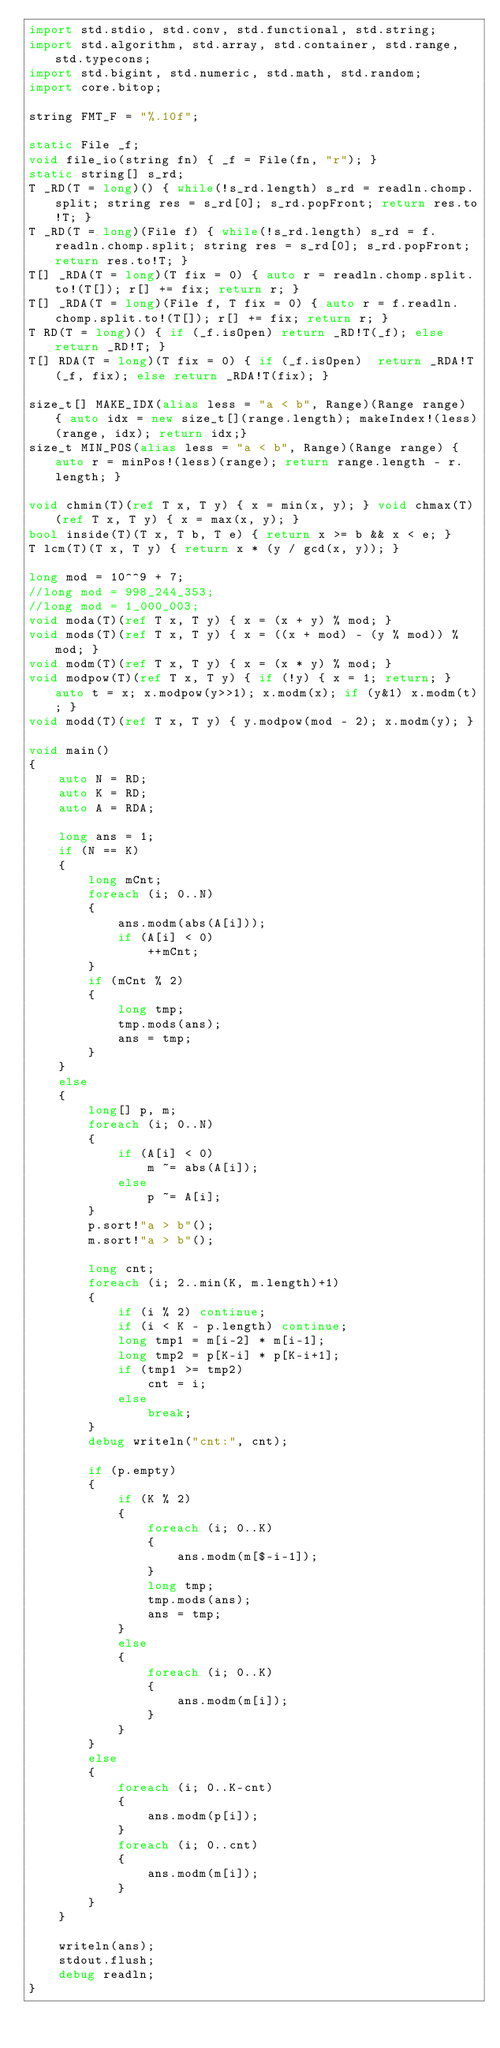Convert code to text. <code><loc_0><loc_0><loc_500><loc_500><_D_>import std.stdio, std.conv, std.functional, std.string;
import std.algorithm, std.array, std.container, std.range, std.typecons;
import std.bigint, std.numeric, std.math, std.random;
import core.bitop;

string FMT_F = "%.10f";

static File _f;
void file_io(string fn) { _f = File(fn, "r"); }
static string[] s_rd;
T _RD(T = long)() { while(!s_rd.length) s_rd = readln.chomp.split; string res = s_rd[0]; s_rd.popFront; return res.to!T; }
T _RD(T = long)(File f) { while(!s_rd.length) s_rd = f.readln.chomp.split; string res = s_rd[0]; s_rd.popFront; return res.to!T; }
T[] _RDA(T = long)(T fix = 0) { auto r = readln.chomp.split.to!(T[]); r[] += fix; return r; }
T[] _RDA(T = long)(File f, T fix = 0) { auto r = f.readln.chomp.split.to!(T[]); r[] += fix; return r; }
T RD(T = long)() { if (_f.isOpen) return _RD!T(_f); else return _RD!T; }
T[] RDA(T = long)(T fix = 0) { if (_f.isOpen)  return _RDA!T(_f, fix); else return _RDA!T(fix); }

size_t[] MAKE_IDX(alias less = "a < b", Range)(Range range) { auto idx = new size_t[](range.length); makeIndex!(less)(range, idx); return idx;}
size_t MIN_POS(alias less = "a < b", Range)(Range range) { auto r = minPos!(less)(range); return range.length - r.length; }

void chmin(T)(ref T x, T y) { x = min(x, y); } void chmax(T)(ref T x, T y) { x = max(x, y); }
bool inside(T)(T x, T b, T e) { return x >= b && x < e; }
T lcm(T)(T x, T y) { return x * (y / gcd(x, y)); }

long mod = 10^^9 + 7;
//long mod = 998_244_353;
//long mod = 1_000_003;
void moda(T)(ref T x, T y) { x = (x + y) % mod; }
void mods(T)(ref T x, T y) { x = ((x + mod) - (y % mod)) % mod; }
void modm(T)(ref T x, T y) { x = (x * y) % mod; }
void modpow(T)(ref T x, T y) { if (!y) { x = 1; return; } auto t = x; x.modpow(y>>1); x.modm(x); if (y&1) x.modm(t); }
void modd(T)(ref T x, T y) { y.modpow(mod - 2); x.modm(y); }

void main()
{
	auto N = RD;
	auto K = RD;
	auto A = RDA;

	long ans = 1;
	if (N == K)
	{
		long mCnt;
		foreach (i; 0..N)
		{
			ans.modm(abs(A[i]));
			if (A[i] < 0)
				++mCnt;
		}
		if (mCnt % 2)
		{
			long tmp;
			tmp.mods(ans);
			ans = tmp;
		}
	}
	else
	{
		long[] p, m;
		foreach (i; 0..N)
		{
			if (A[i] < 0)
				m ~= abs(A[i]);
			else
				p ~= A[i];
		}
		p.sort!"a > b"();
		m.sort!"a > b"();

		long cnt;
		foreach (i; 2..min(K, m.length)+1)
		{
			if (i % 2) continue;
			if (i < K - p.length) continue;
			long tmp1 = m[i-2] * m[i-1];
			long tmp2 = p[K-i] * p[K-i+1];
			if (tmp1 >= tmp2)
				cnt = i;
			else
				break;
		}
		debug writeln("cnt:", cnt);

		if (p.empty)
		{
			if (K % 2)
			{
				foreach (i; 0..K)
				{
					ans.modm(m[$-i-1]);
				}
				long tmp;
				tmp.mods(ans);
				ans = tmp;
			}
			else
			{
				foreach (i; 0..K)
				{
					ans.modm(m[i]);
				}
			}
		}
		else
		{
			foreach (i; 0..K-cnt)
			{
				ans.modm(p[i]);
			}
			foreach (i; 0..cnt)
			{
				ans.modm(m[i]);
			}
		}
	}

	writeln(ans);
	stdout.flush;
	debug readln;
}</code> 